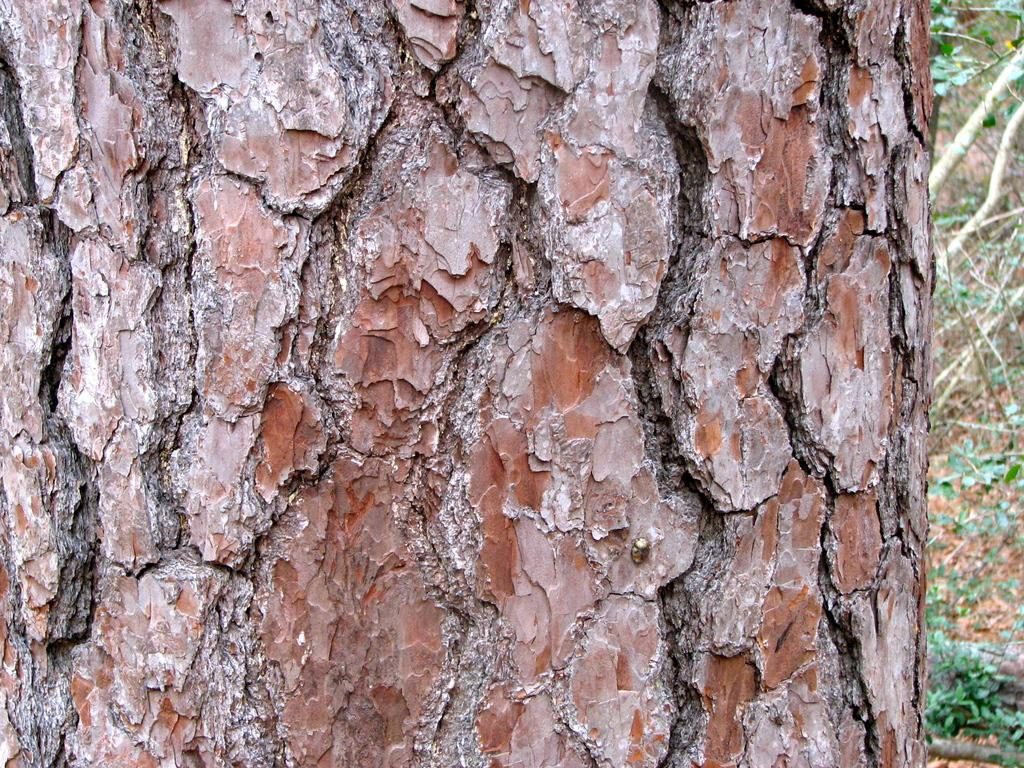What object is the main subject of the image? There is a trunk in the image. What is the color of the trunk? The trunk is brown in color. What can be seen in the background of the image? There are trees in the background of the image. What is the color of the trees? The trees are green in color. Can you tell me how many pigs are playing with the sister in the image? There is no mention of a sister or pigs in the image; it only features a trunk and trees in the background. 